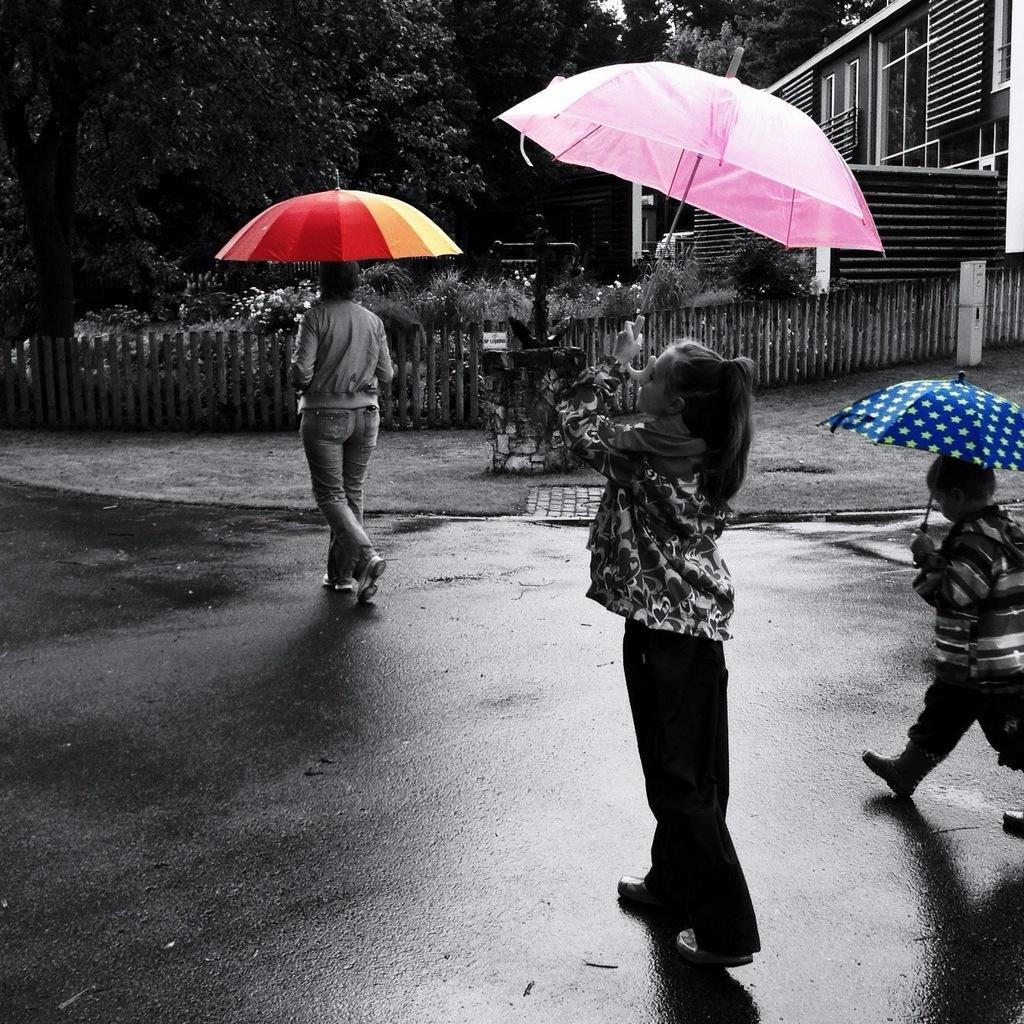Describe this image in one or two sentences. Front these three people are holding umbrellas. Background there is a fence, building, plants and trees.  